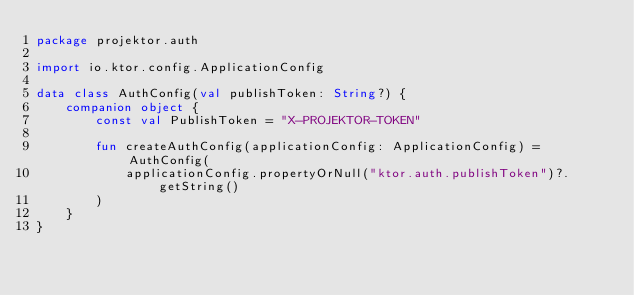Convert code to text. <code><loc_0><loc_0><loc_500><loc_500><_Kotlin_>package projektor.auth

import io.ktor.config.ApplicationConfig

data class AuthConfig(val publishToken: String?) {
    companion object {
        const val PublishToken = "X-PROJEKTOR-TOKEN"

        fun createAuthConfig(applicationConfig: ApplicationConfig) = AuthConfig(
            applicationConfig.propertyOrNull("ktor.auth.publishToken")?.getString()
        )
    }
}
</code> 